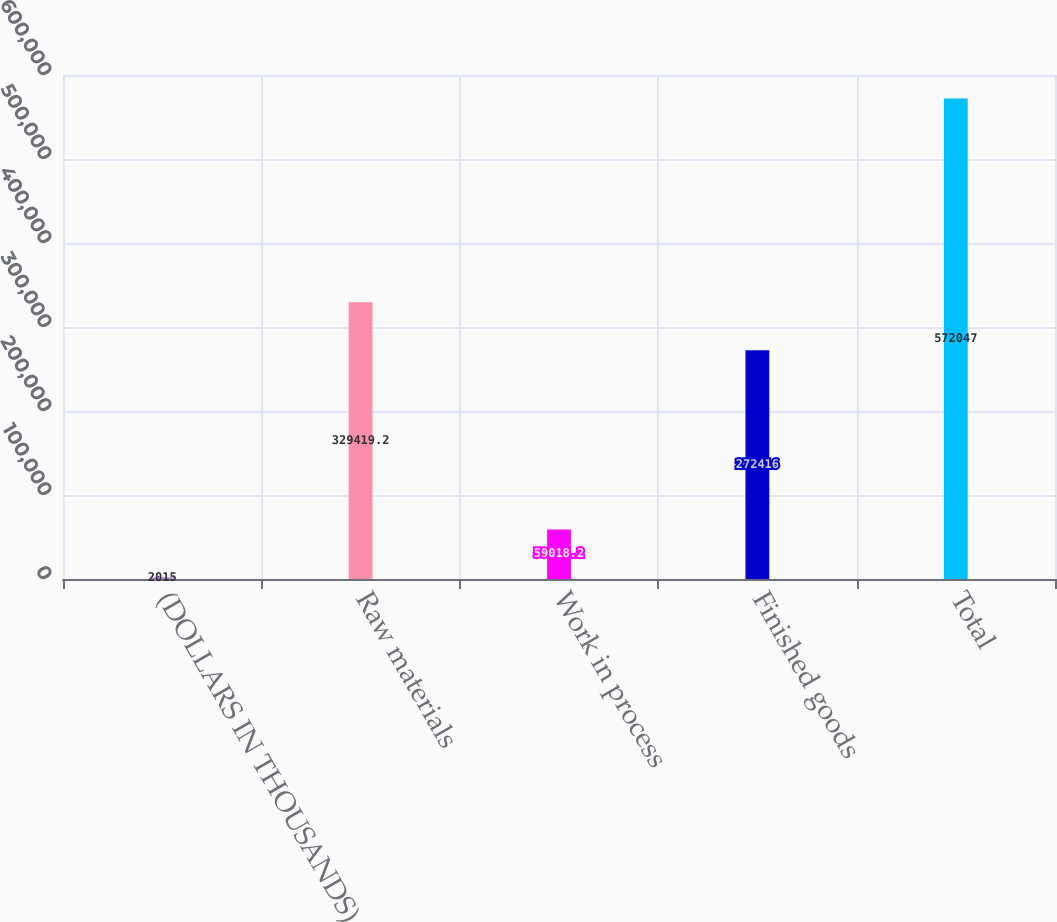Convert chart. <chart><loc_0><loc_0><loc_500><loc_500><bar_chart><fcel>(DOLLARS IN THOUSANDS)<fcel>Raw materials<fcel>Work in process<fcel>Finished goods<fcel>Total<nl><fcel>2015<fcel>329419<fcel>59018.2<fcel>272416<fcel>572047<nl></chart> 